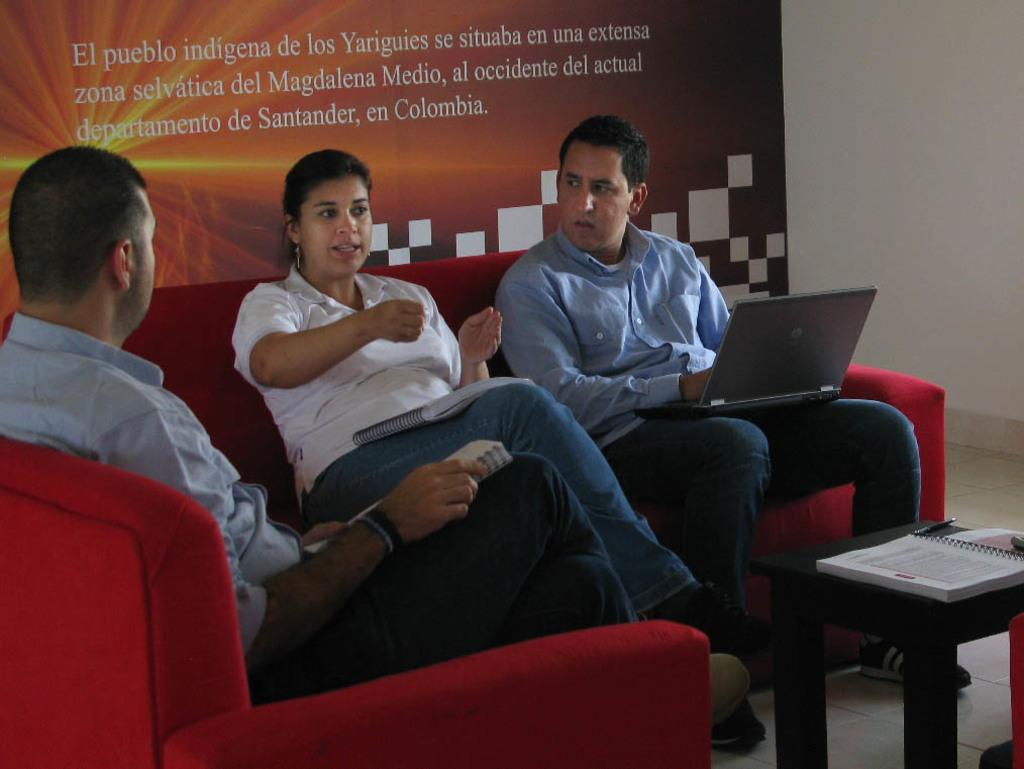How many people are in the image? There are two people in the image, a woman and a man. What are the woman and man doing in the image? The woman and man are sitting on a sofa and talking to each other. What is one of the men doing while sitting on the sofa? One of the men is operating a laptop. What objects can be seen on the table in the image? There is a book and a pen placed on the table. What is the end of the attack in the image? There is no attack present in the image, so it is not possible to determine the end of an attack. 